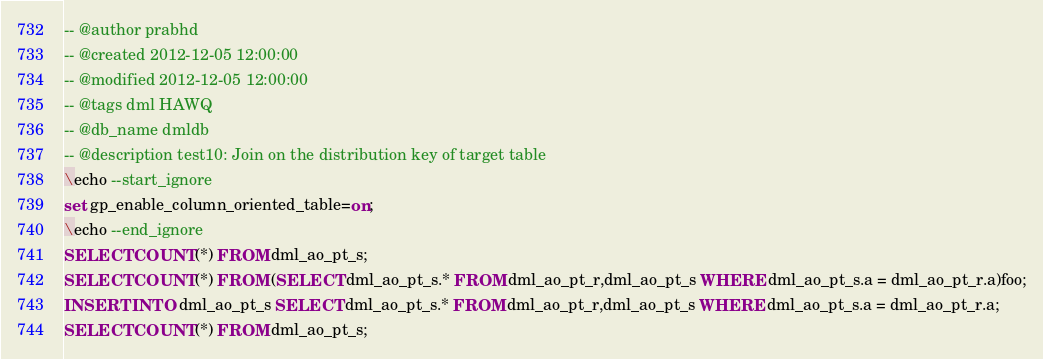Convert code to text. <code><loc_0><loc_0><loc_500><loc_500><_SQL_>-- @author prabhd 
-- @created 2012-12-05 12:00:00 
-- @modified 2012-12-05 12:00:00 
-- @tags dml HAWQ 
-- @db_name dmldb
-- @description test10: Join on the distribution key of target table
\echo --start_ignore
set gp_enable_column_oriented_table=on;
\echo --end_ignore
SELECT COUNT(*) FROM dml_ao_pt_s;
SELECT COUNT(*) FROM (SELECT dml_ao_pt_s.* FROM dml_ao_pt_r,dml_ao_pt_s WHERE dml_ao_pt_s.a = dml_ao_pt_r.a)foo;
INSERT INTO dml_ao_pt_s SELECT dml_ao_pt_s.* FROM dml_ao_pt_r,dml_ao_pt_s WHERE dml_ao_pt_s.a = dml_ao_pt_r.a;
SELECT COUNT(*) FROM dml_ao_pt_s;
</code> 